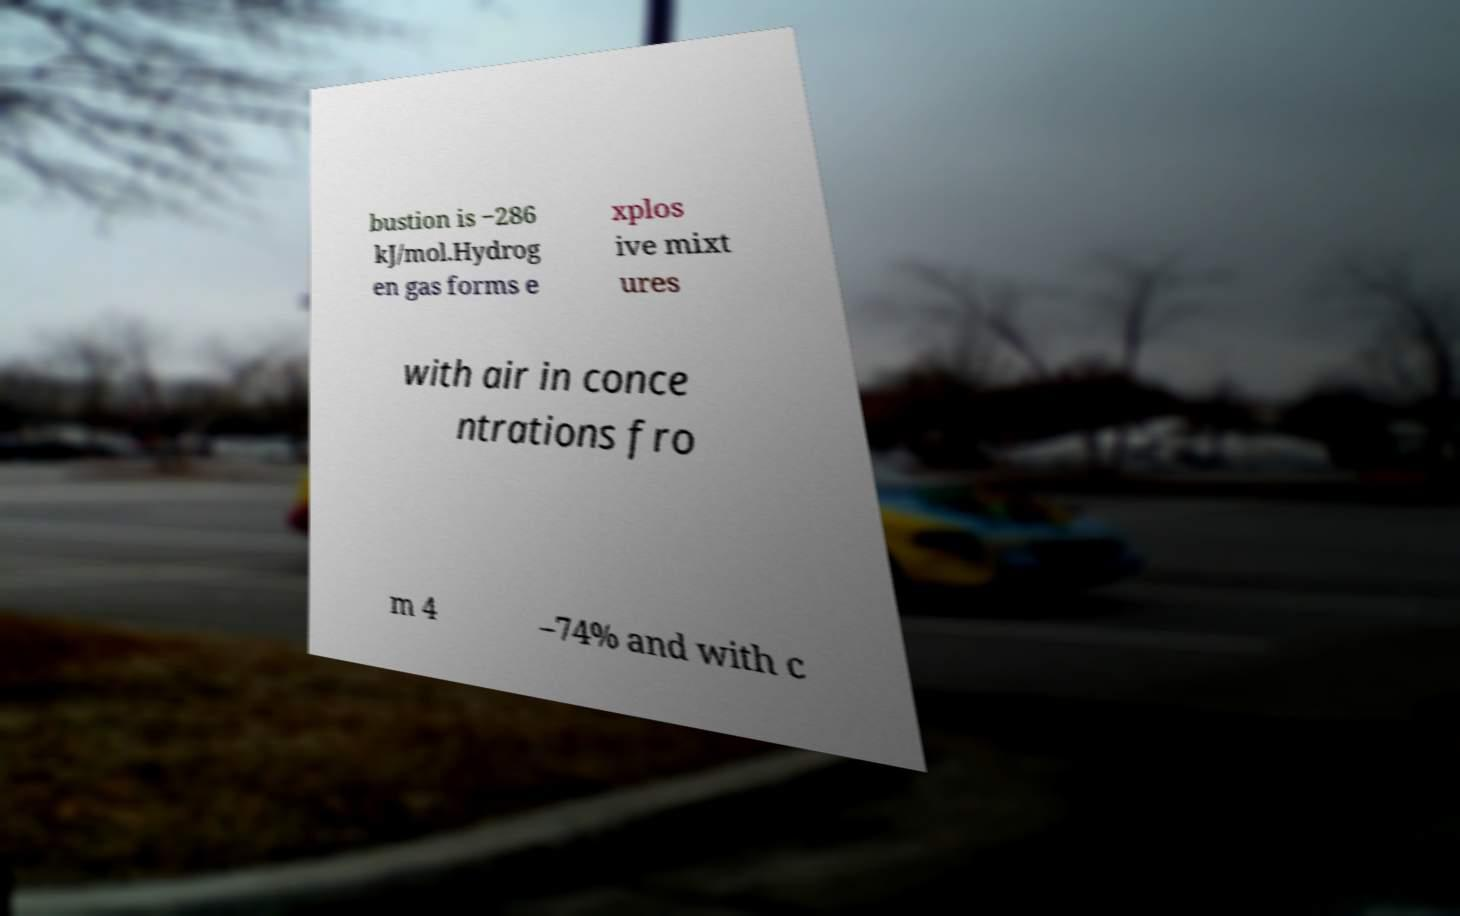I need the written content from this picture converted into text. Can you do that? bustion is −286 kJ/mol.Hydrog en gas forms e xplos ive mixt ures with air in conce ntrations fro m 4 –74% and with c 